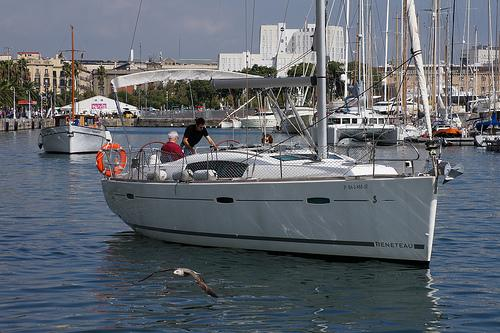Express the atmosphere of the image in a brief statement. An atmosphere of calmness and leisure fills the air, as boats rest in the marina and people enjoy their time on the water. Imagine you're a painter and describe the image as if it's your artwork. In my latest painting, boats find solace in a tranquil marina, while seagulls grace the sky and passengers create stories that echo through the water, framed with white buildings and vibrant life preservers. List the main elements in the image and their characteristics. A ship, white color, curved boat; water body, calm; sky; building, white; pole, white; tree; marina, boat-filled; seagull, flying low; life preserver, orange; people on sailboat, red and black shirt; bird, flying below, white head. Briefly describe the activities of the people in the image. Two men, one in a red shirt and the other in a black shirt, are on a sailboat, engaged in conversation or activities related to boating. Provide a brief overall summary of the image. The image depicts a peaceful marina filled with boats and people enjoying their time, featuring calm waters, flying seagulls, and white buildings in the background. Write an engaging headline for a news article about the image. "Sail Away: An Afternoon of Relaxation and Adventure at the Picturesque Marina" In a poetic way, describe the scene in the image. A serene marina, boats docked gracefully, white sails gleaming; calm waters embrace, sea-gulls dance above, orange buoys invite adventure; stories unfold, on a vessel adorned, men and women, united by the wind. Turn this image into a story, starting with "Once upon a time." Once upon a time, in a tranquil marina filled with serene waters, sailboats gathered as the heart of a beautiful day, while spirited men and women wearing red and black shirts exchanged laughter and stories, as a curious seagull soared in the sky, whispering the tales of the sea. What emotions does this image evoke, and why? The image evokes serenity, leisure, and warmth, as the calm water, boat-filled marina, and people enjoying their time on the boats creates a sense of relaxation and enjoyment. Narrate the activities happening in the image in a single sentence. Amidst a tranquil marina, sailboats gently sway as their passengers mingle, and a seagull glides gently below them on the peaceful water. 